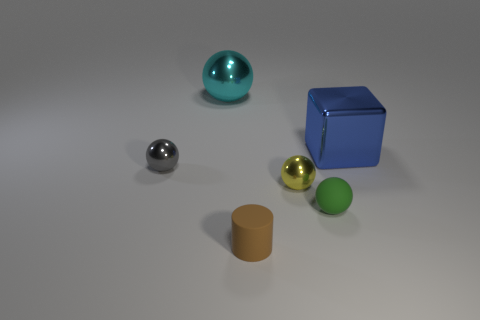Add 2 blue things. How many objects exist? 8 Subtract all brown balls. Subtract all gray cubes. How many balls are left? 4 Subtract all cylinders. How many objects are left? 5 Subtract all green metal balls. Subtract all small gray spheres. How many objects are left? 5 Add 3 small gray metal spheres. How many small gray metal spheres are left? 4 Add 2 big green rubber cylinders. How many big green rubber cylinders exist? 2 Subtract 0 yellow blocks. How many objects are left? 6 